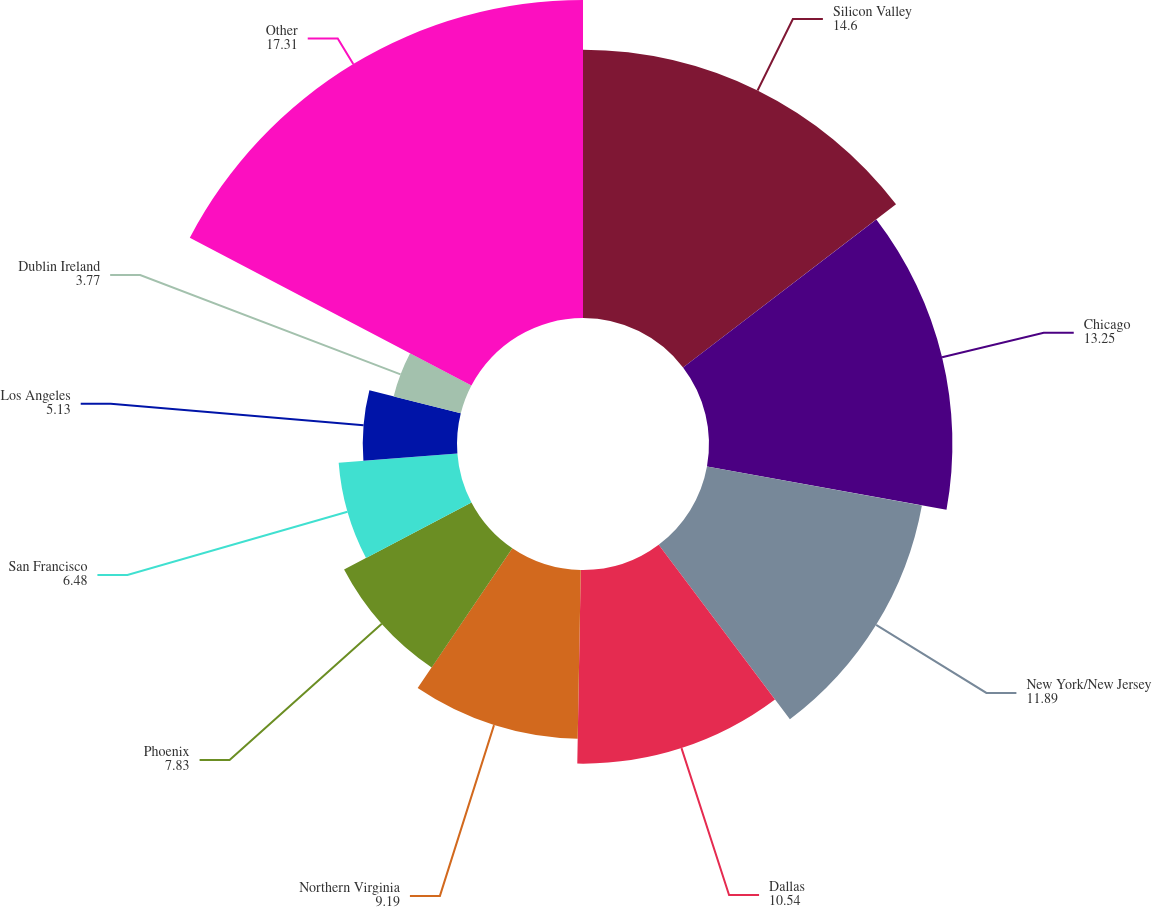Convert chart. <chart><loc_0><loc_0><loc_500><loc_500><pie_chart><fcel>Silicon Valley<fcel>Chicago<fcel>New York/New Jersey<fcel>Dallas<fcel>Northern Virginia<fcel>Phoenix<fcel>San Francisco<fcel>Los Angeles<fcel>Dublin Ireland<fcel>Other<nl><fcel>14.6%<fcel>13.25%<fcel>11.89%<fcel>10.54%<fcel>9.19%<fcel>7.83%<fcel>6.48%<fcel>5.13%<fcel>3.77%<fcel>17.31%<nl></chart> 